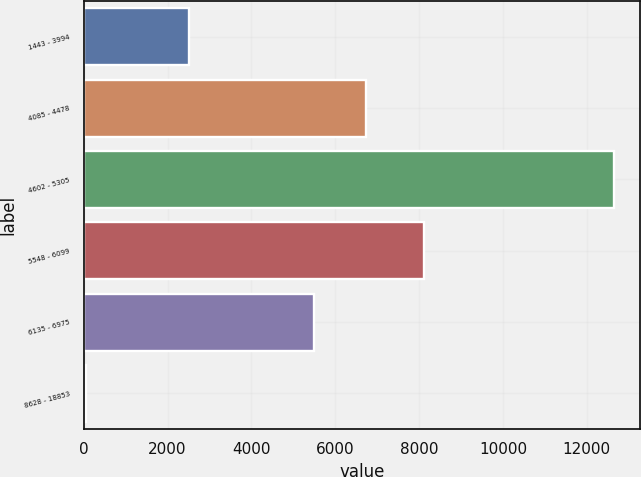Convert chart to OTSL. <chart><loc_0><loc_0><loc_500><loc_500><bar_chart><fcel>1443 - 3994<fcel>4085 - 4478<fcel>4602 - 5305<fcel>5548 - 6099<fcel>6135 - 6975<fcel>8628 - 18853<nl><fcel>2509<fcel>6741.8<fcel>12644<fcel>8127<fcel>5482<fcel>46<nl></chart> 